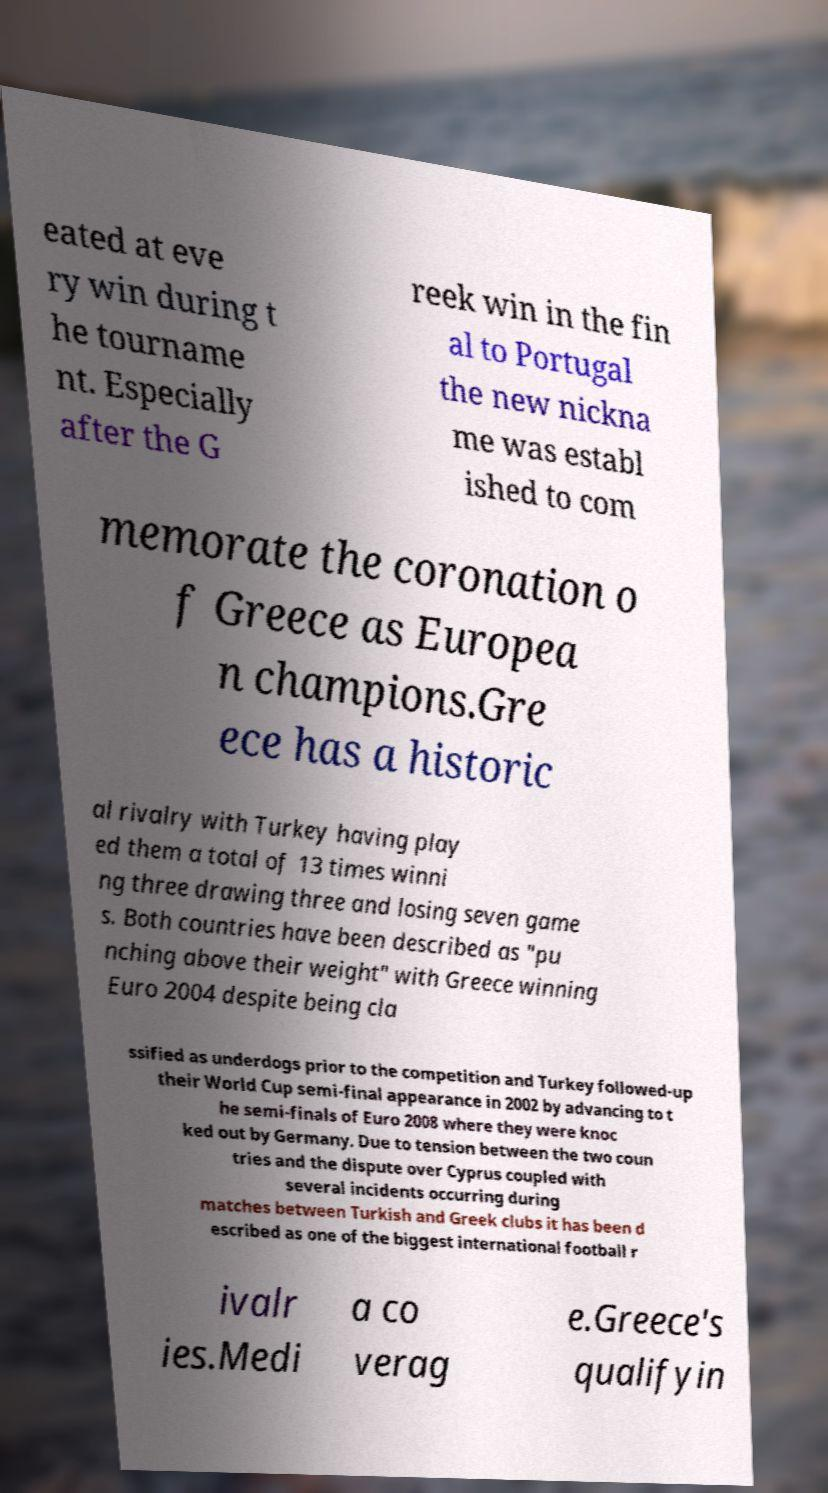Could you extract and type out the text from this image? eated at eve ry win during t he tourname nt. Especially after the G reek win in the fin al to Portugal the new nickna me was establ ished to com memorate the coronation o f Greece as Europea n champions.Gre ece has a historic al rivalry with Turkey having play ed them a total of 13 times winni ng three drawing three and losing seven game s. Both countries have been described as "pu nching above their weight" with Greece winning Euro 2004 despite being cla ssified as underdogs prior to the competition and Turkey followed-up their World Cup semi-final appearance in 2002 by advancing to t he semi-finals of Euro 2008 where they were knoc ked out by Germany. Due to tension between the two coun tries and the dispute over Cyprus coupled with several incidents occurring during matches between Turkish and Greek clubs it has been d escribed as one of the biggest international football r ivalr ies.Medi a co verag e.Greece's qualifyin 